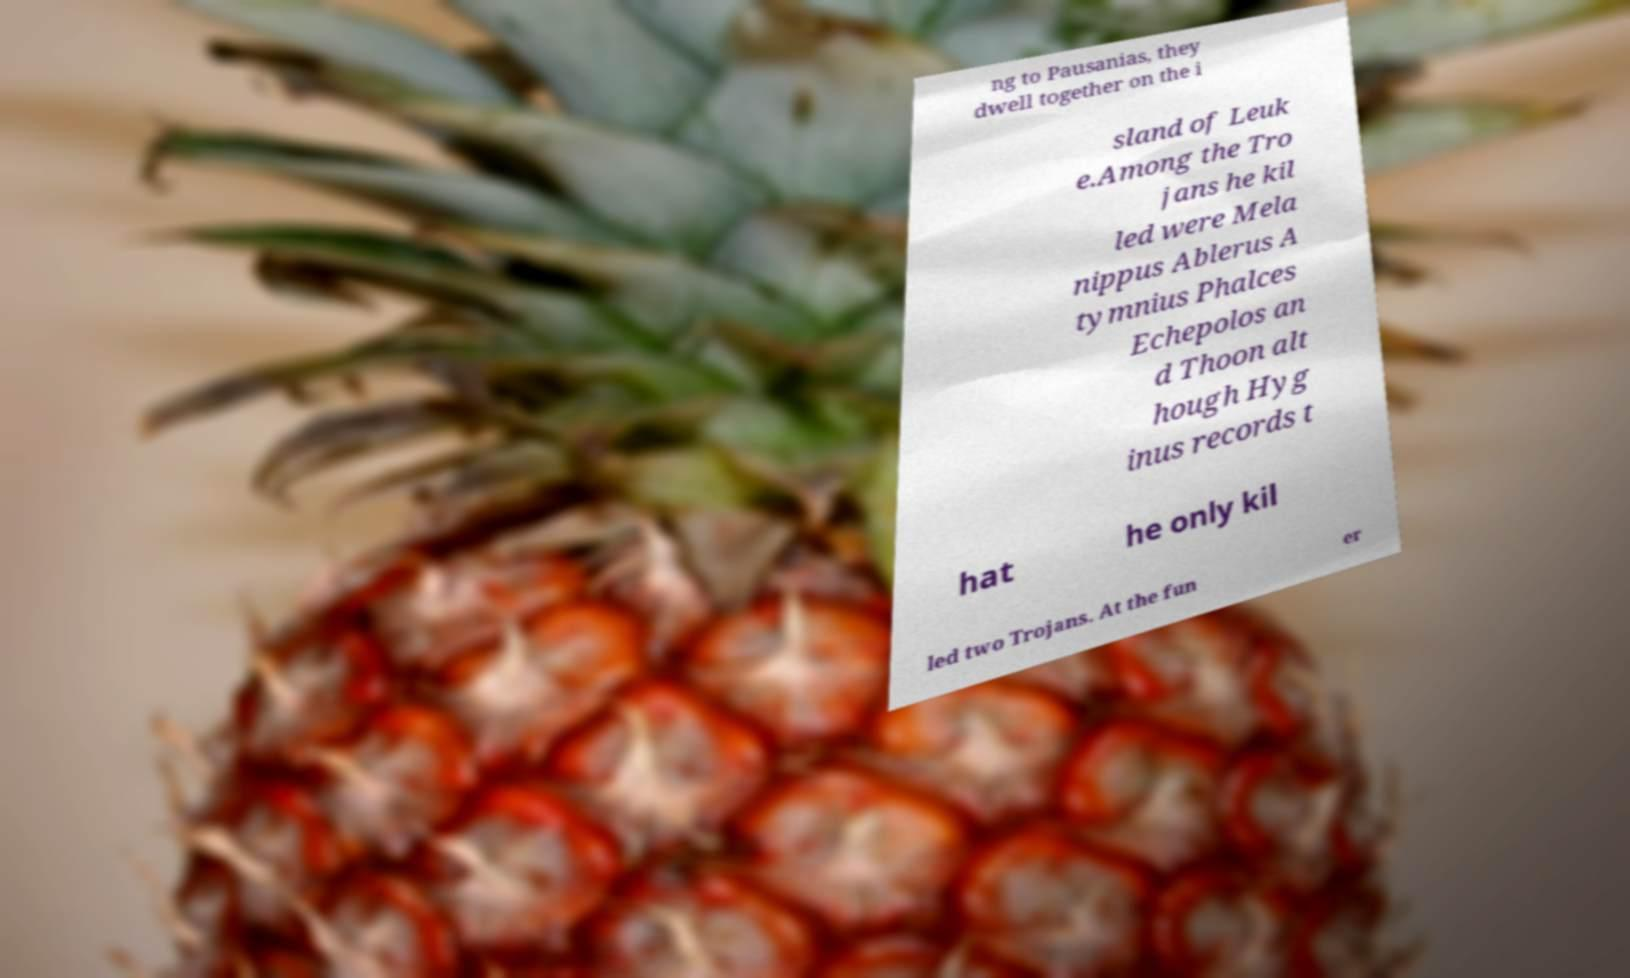Please identify and transcribe the text found in this image. ng to Pausanias, they dwell together on the i sland of Leuk e.Among the Tro jans he kil led were Mela nippus Ablerus A tymnius Phalces Echepolos an d Thoon alt hough Hyg inus records t hat he only kil led two Trojans. At the fun er 